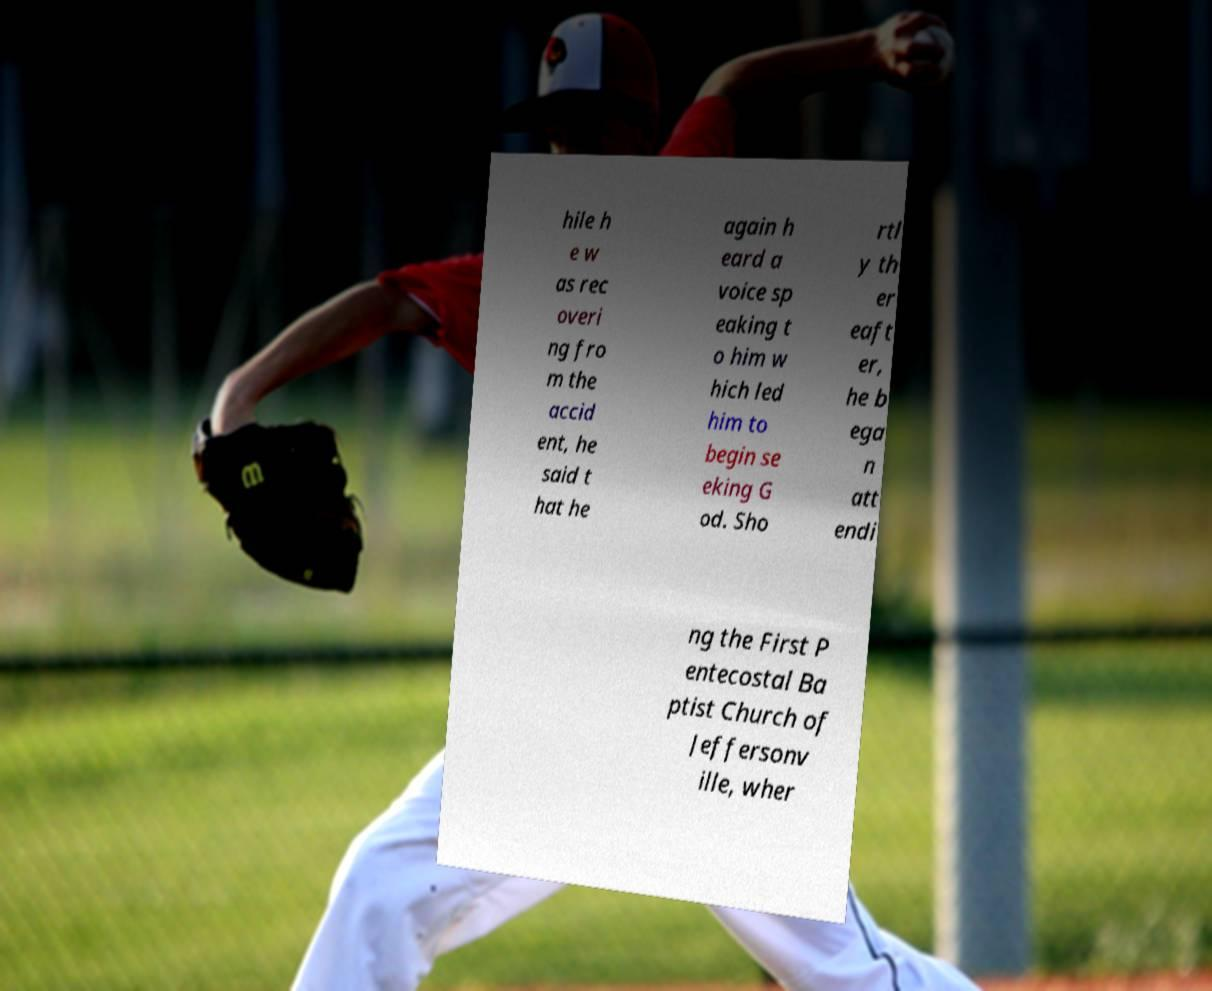Could you extract and type out the text from this image? hile h e w as rec overi ng fro m the accid ent, he said t hat he again h eard a voice sp eaking t o him w hich led him to begin se eking G od. Sho rtl y th er eaft er, he b ega n att endi ng the First P entecostal Ba ptist Church of Jeffersonv ille, wher 